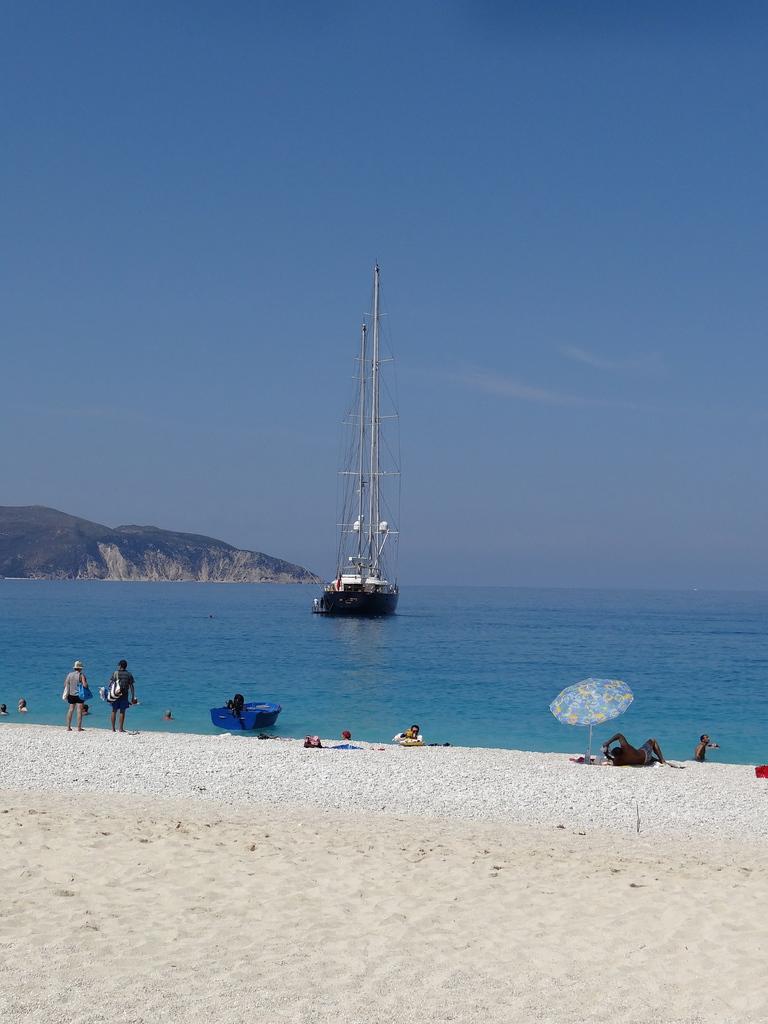Describe this image in one or two sentences. In this image we can see people and two of them are standing. Here we can see sand, water, ship, boat, umbrella, and mountain. In the background there is sky with clouds. 